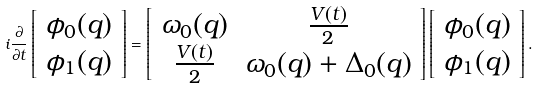Convert formula to latex. <formula><loc_0><loc_0><loc_500><loc_500>i \frac { \partial } { \partial t } \left [ \begin{array} { c } \phi _ { 0 } ( { q } ) \\ \phi _ { 1 } ( { q } ) \end{array} \right ] = \left [ \begin{array} { c c } \omega _ { 0 } ( { q } ) & \frac { V ( t ) } { 2 } \\ \frac { V ( t ) } { 2 } & \omega _ { 0 } ( { q } ) + \Delta _ { 0 } ( { q } ) \end{array} \right ] \left [ \begin{array} { c } \phi _ { 0 } ( { q } ) \\ \phi _ { 1 } ( { q } ) \end{array} \right ] .</formula> 